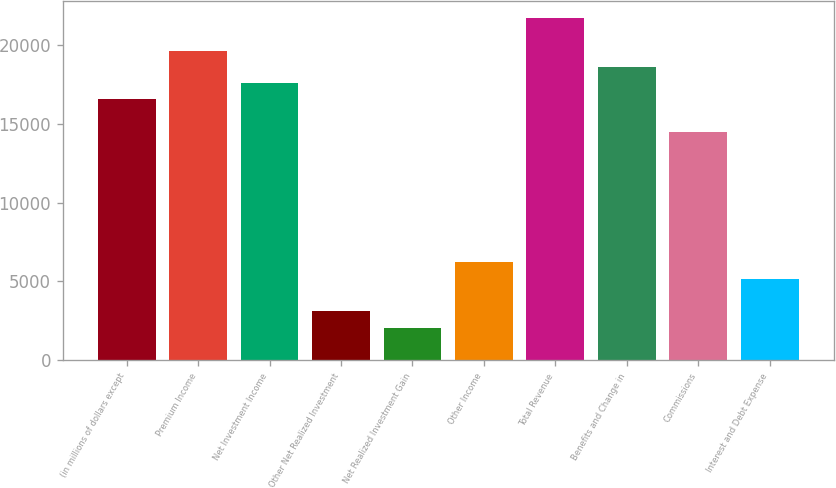Convert chart. <chart><loc_0><loc_0><loc_500><loc_500><bar_chart><fcel>(in millions of dollars except<fcel>Premium Income<fcel>Net Investment Income<fcel>Other Net Realized Investment<fcel>Net Realized Investment Gain<fcel>Other Income<fcel>Total Revenue<fcel>Benefits and Change in<fcel>Commissions<fcel>Interest and Debt Expense<nl><fcel>16564.2<fcel>19669.4<fcel>17599.2<fcel>3108.41<fcel>2073.35<fcel>6213.59<fcel>21739.5<fcel>18634.3<fcel>14494.1<fcel>5178.53<nl></chart> 